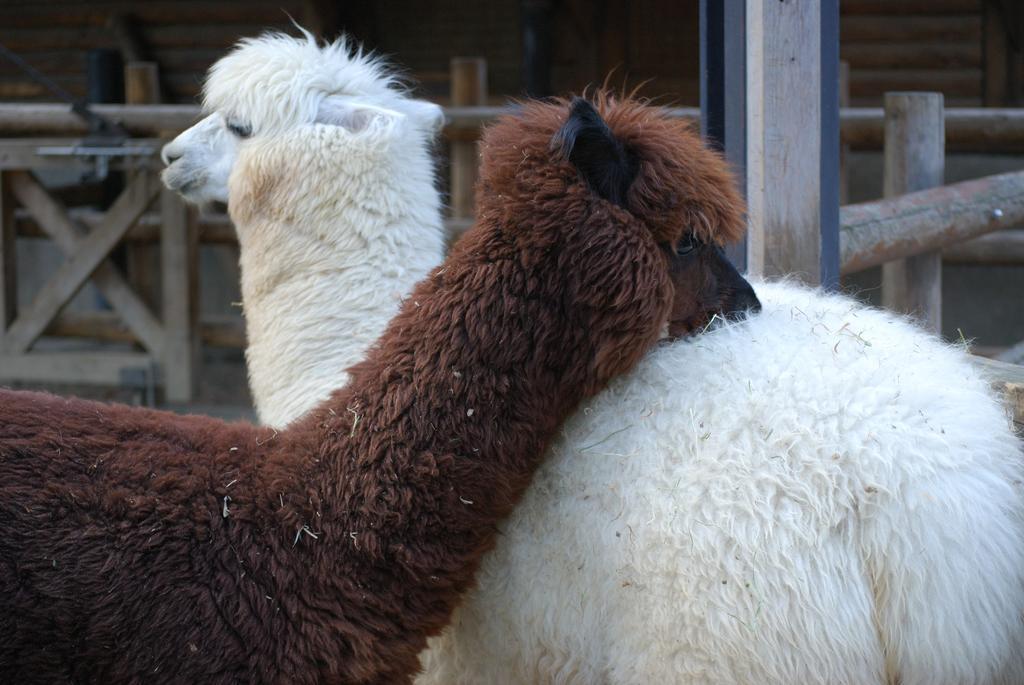Can you describe this image briefly? In the image we can see tow Llama, white and brown in color. Here we can see wooden fence. 